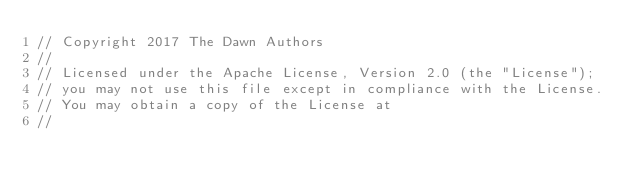Convert code to text. <code><loc_0><loc_0><loc_500><loc_500><_C++_>// Copyright 2017 The Dawn Authors
//
// Licensed under the Apache License, Version 2.0 (the "License");
// you may not use this file except in compliance with the License.
// You may obtain a copy of the License at
//</code> 